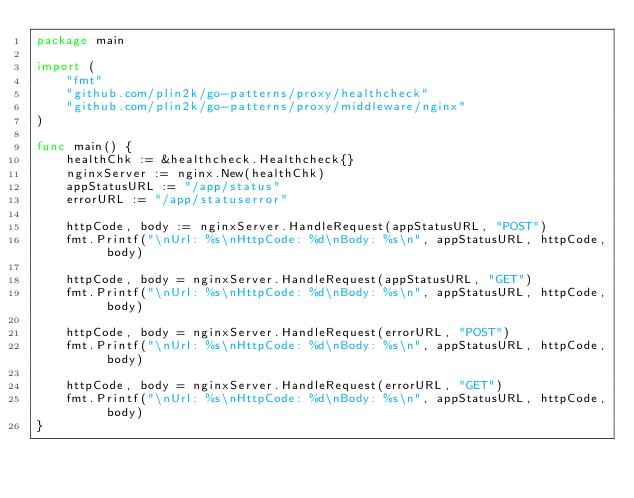Convert code to text. <code><loc_0><loc_0><loc_500><loc_500><_Go_>package main

import (
	"fmt"
	"github.com/plin2k/go-patterns/proxy/healthcheck"
	"github.com/plin2k/go-patterns/proxy/middleware/nginx"
)

func main() {
	healthChk := &healthcheck.Healthcheck{}
	nginxServer := nginx.New(healthChk)
	appStatusURL := "/app/status"
	errorURL := "/app/statuserror"

	httpCode, body := nginxServer.HandleRequest(appStatusURL, "POST")
	fmt.Printf("\nUrl: %s\nHttpCode: %d\nBody: %s\n", appStatusURL, httpCode, body)

	httpCode, body = nginxServer.HandleRequest(appStatusURL, "GET")
	fmt.Printf("\nUrl: %s\nHttpCode: %d\nBody: %s\n", appStatusURL, httpCode, body)

	httpCode, body = nginxServer.HandleRequest(errorURL, "POST")
	fmt.Printf("\nUrl: %s\nHttpCode: %d\nBody: %s\n", appStatusURL, httpCode, body)

	httpCode, body = nginxServer.HandleRequest(errorURL, "GET")
	fmt.Printf("\nUrl: %s\nHttpCode: %d\nBody: %s\n", appStatusURL, httpCode, body)
}
</code> 